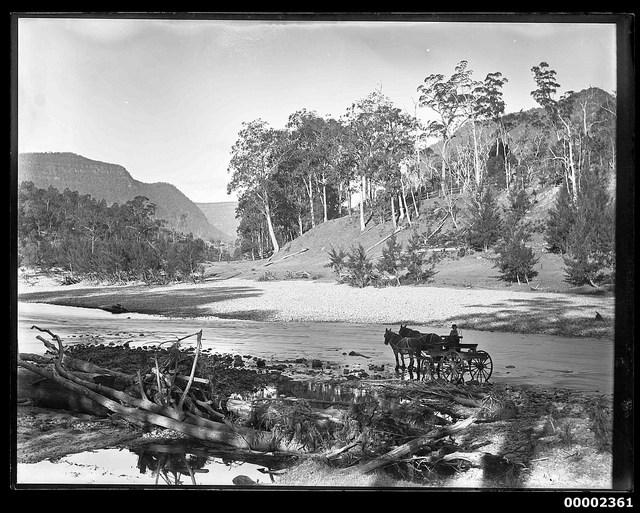Extract all visible text content from this image. 00002361 